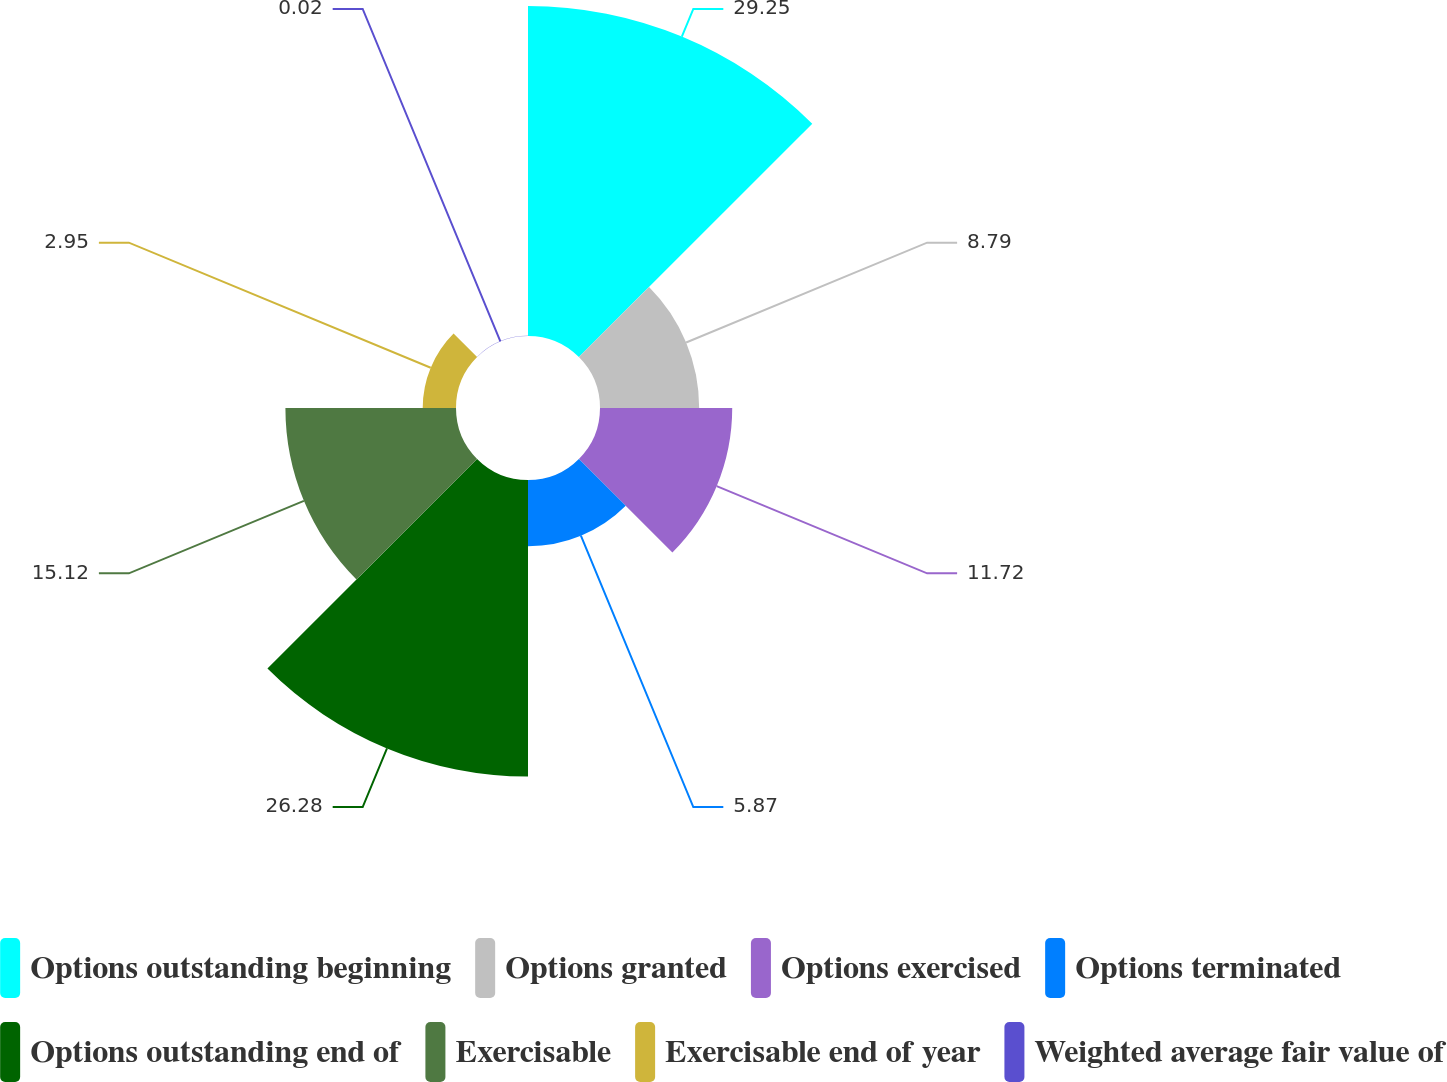Convert chart to OTSL. <chart><loc_0><loc_0><loc_500><loc_500><pie_chart><fcel>Options outstanding beginning<fcel>Options granted<fcel>Options exercised<fcel>Options terminated<fcel>Options outstanding end of<fcel>Exercisable<fcel>Exercisable end of year<fcel>Weighted average fair value of<nl><fcel>29.25%<fcel>8.79%<fcel>11.72%<fcel>5.87%<fcel>26.28%<fcel>15.12%<fcel>2.95%<fcel>0.02%<nl></chart> 